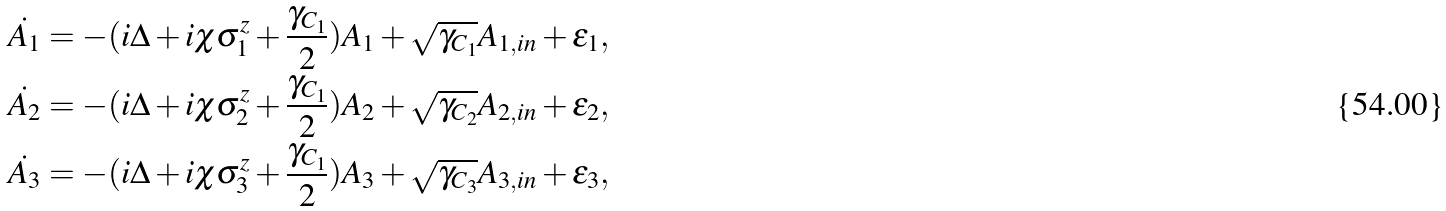Convert formula to latex. <formula><loc_0><loc_0><loc_500><loc_500>\dot { A _ { 1 } } & = - ( i \Delta + i \chi \sigma _ { 1 } ^ { z } + \frac { \gamma _ { C _ { 1 } } } { 2 } ) A _ { 1 } + \sqrt { \gamma _ { C _ { 1 } } } A _ { 1 , i n } + \varepsilon _ { 1 } , \\ \dot { A _ { 2 } } & = - ( i \Delta + i \chi \sigma _ { 2 } ^ { z } + \frac { \gamma _ { C _ { 1 } } } { 2 } ) A _ { 2 } + \sqrt { \gamma _ { C _ { 2 } } } A _ { 2 , i n } + \varepsilon _ { 2 } , \\ \dot { A _ { 3 } } & = - ( i \Delta + i \chi \sigma _ { 3 } ^ { z } + \frac { \gamma _ { C _ { 1 } } } { 2 } ) A _ { 3 } + \sqrt { \gamma _ { C _ { 3 } } } A _ { 3 , i n } + \varepsilon _ { 3 } ,</formula> 